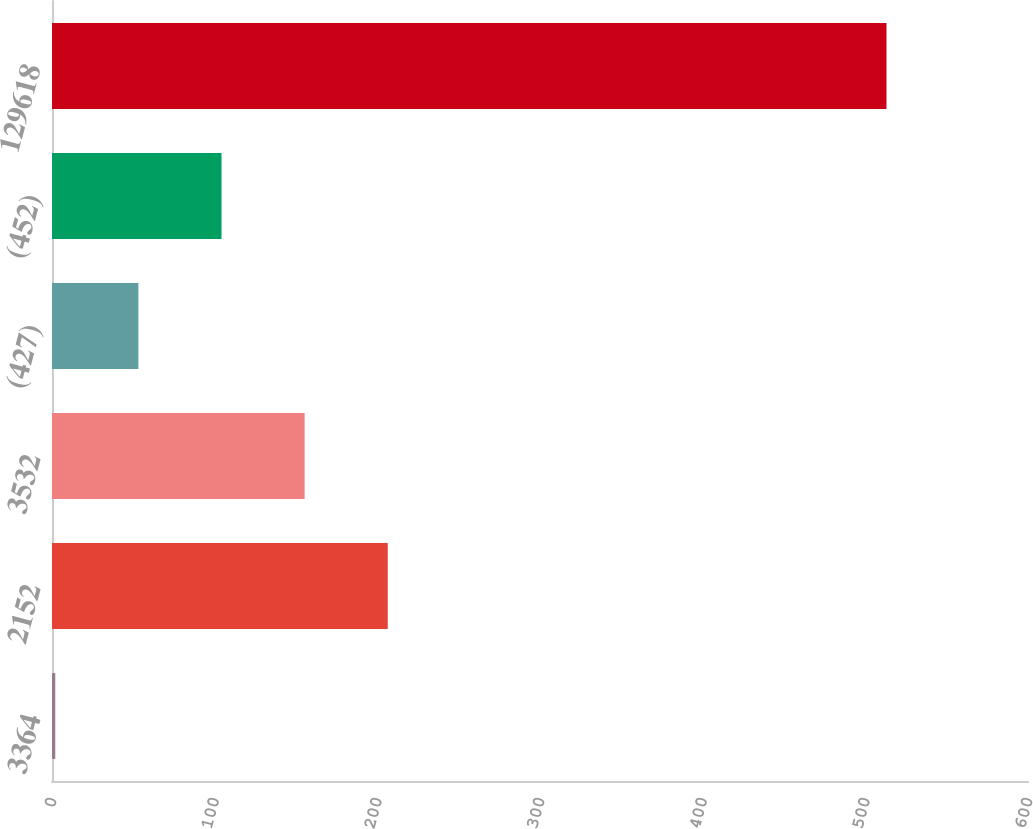Convert chart to OTSL. <chart><loc_0><loc_0><loc_500><loc_500><bar_chart><fcel>3364<fcel>2152<fcel>3532<fcel>(427)<fcel>(452)<fcel>129618<nl><fcel>2<fcel>206.4<fcel>155.3<fcel>53.1<fcel>104.2<fcel>513<nl></chart> 